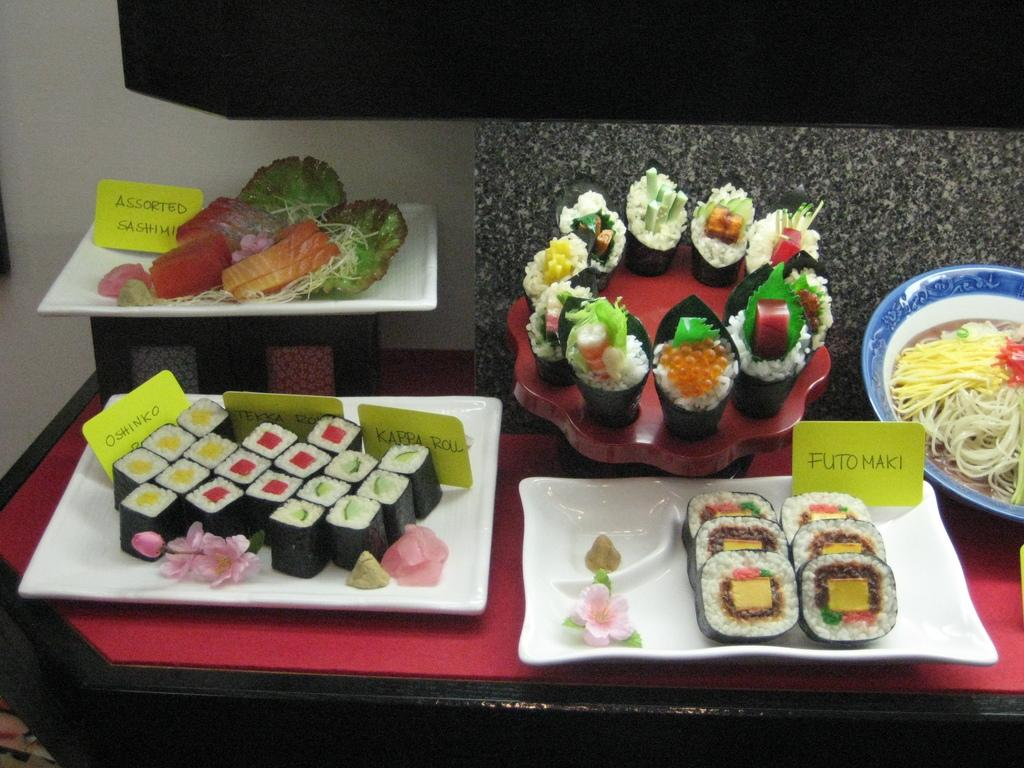What is present on the table in the image? There are different food items in plates on the table. Where is the table located in relation to the wall? The wall is in the background of the image, which suggests that the table is in front of the wall. Can you describe the food items on the plates? The provided facts do not specify the types of food items on the plates. What type of spy equipment can be seen on the table in the image? There is no spy equipment present in the image; it features food items on plates on a table. What hobbies are the people in the image engaged in? The provided facts do not mention any people in the image, so their hobbies cannot be determined. 